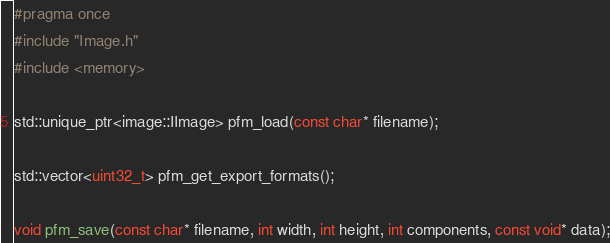<code> <loc_0><loc_0><loc_500><loc_500><_C_>#pragma once
#include "Image.h"
#include <memory>

std::unique_ptr<image::IImage> pfm_load(const char* filename);

std::vector<uint32_t> pfm_get_export_formats();

void pfm_save(const char* filename, int width, int height, int components, const void* data);</code> 